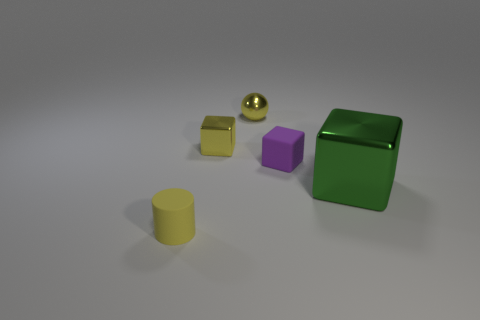Add 3 matte cylinders. How many objects exist? 8 Subtract all shiny blocks. How many blocks are left? 1 Subtract 1 cubes. How many cubes are left? 2 Subtract all cylinders. How many objects are left? 4 Subtract 0 gray cylinders. How many objects are left? 5 Subtract all gray cylinders. Subtract all brown cubes. How many cylinders are left? 1 Subtract all tiny rubber cubes. Subtract all big gray cylinders. How many objects are left? 4 Add 5 yellow shiny spheres. How many yellow shiny spheres are left? 6 Add 3 big blue metallic cubes. How many big blue metallic cubes exist? 3 